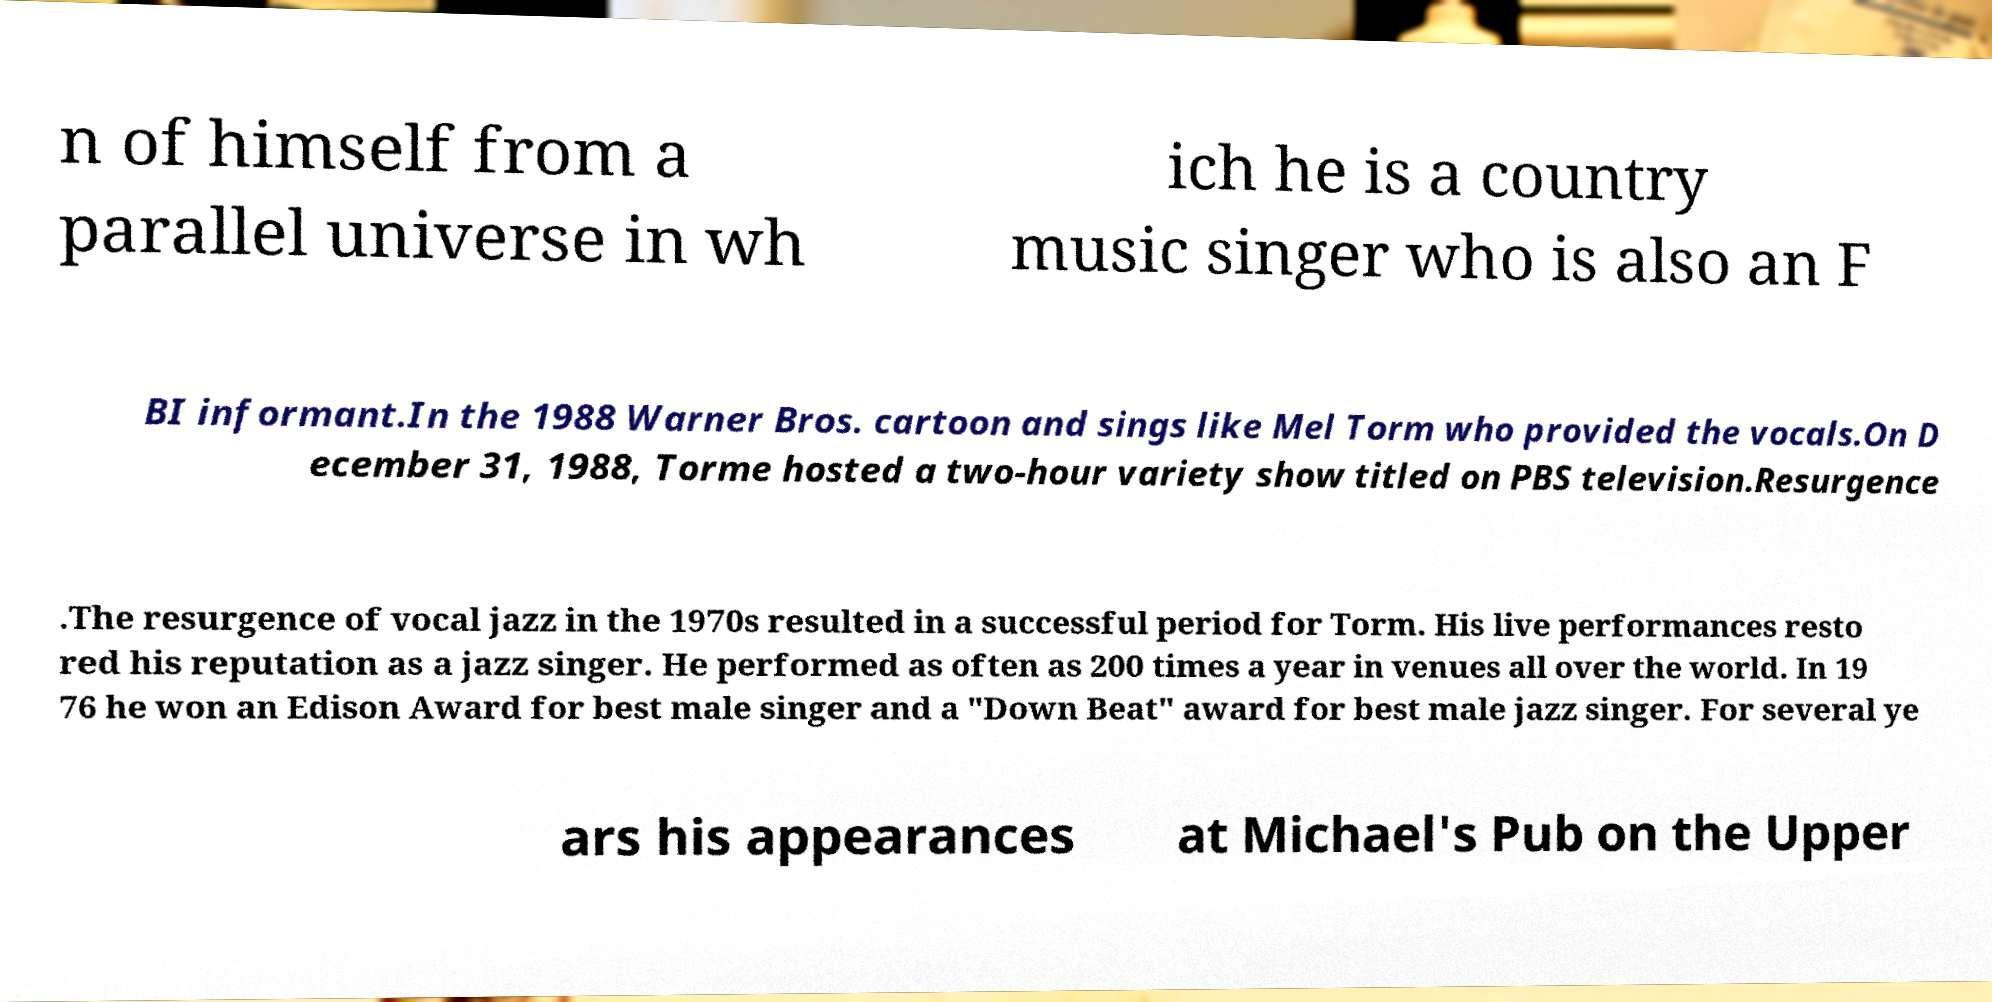Can you accurately transcribe the text from the provided image for me? n of himself from a parallel universe in wh ich he is a country music singer who is also an F BI informant.In the 1988 Warner Bros. cartoon and sings like Mel Torm who provided the vocals.On D ecember 31, 1988, Torme hosted a two-hour variety show titled on PBS television.Resurgence .The resurgence of vocal jazz in the 1970s resulted in a successful period for Torm. His live performances resto red his reputation as a jazz singer. He performed as often as 200 times a year in venues all over the world. In 19 76 he won an Edison Award for best male singer and a "Down Beat" award for best male jazz singer. For several ye ars his appearances at Michael's Pub on the Upper 